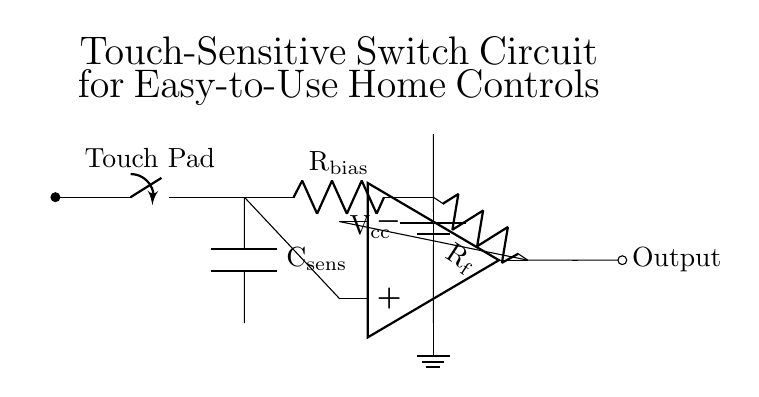What component is used to detect touch? The circuit diagram includes a touch pad that acts as the touch-sensitive component, detecting user interaction.
Answer: Touch Pad What is the function of the capacitor in this circuit? The capacitor, labeled \(C_{\text{sens}}\), is connected to the touch pad and helps in smoothing out any noise and stabilizing the voltage level that is sensed by the circuit.
Answer: Smoothing What is the purpose of the resistor labeled \(R_{\text{bias}}\)? The resistor \(R_{\text{bias}}\) provides a biasing current to the touch pad, ensuring that the op-amp functions correctly when the pad is activated.
Answer: Biasing What type of component is used for signal amplification in this circuit? An operational amplifier (op-amp) is used in the circuit to amplify the signal generated from the touch pad input, making it suitable for triggering other devices.
Answer: Op-amp How many resistors are present in this circuit? There are two resistors in the circuit: \(R_{\text{bias}}\) and \(R_{\text{f}}\), which are used for different functions in signal processing and feedback.
Answer: Two What happens at the output of this circuit? The output of the op-amp generates a signal that can be used to control other household appliances, providing an easy interface for users to turn devices on and off.
Answer: Control signal What does the power source in the circuit provide? The power source provides voltage to the circuit, indicated as \(V_{\text{cc}}\), essential for the operation of all components, particularly the op-amp.
Answer: Voltage 